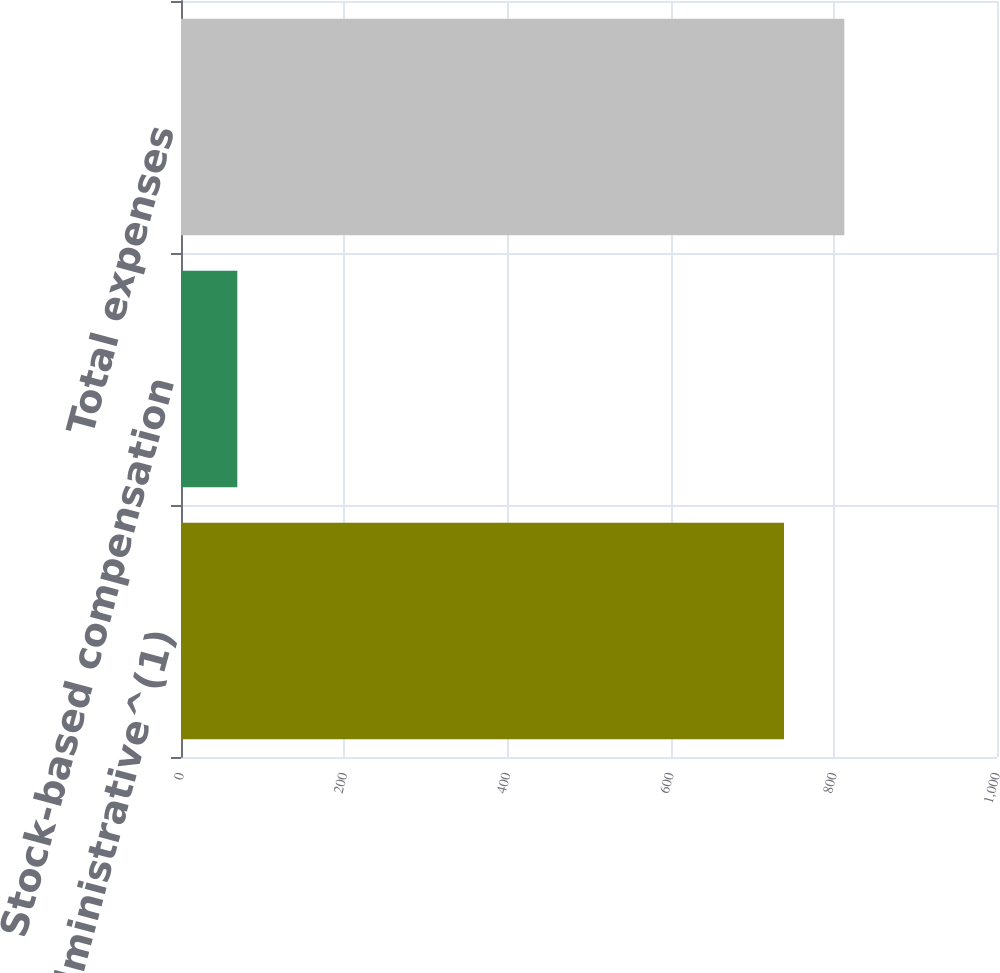Convert chart to OTSL. <chart><loc_0><loc_0><loc_500><loc_500><bar_chart><fcel>General and administrative^(1)<fcel>Stock-based compensation<fcel>Total expenses<nl><fcel>739<fcel>69<fcel>812.9<nl></chart> 